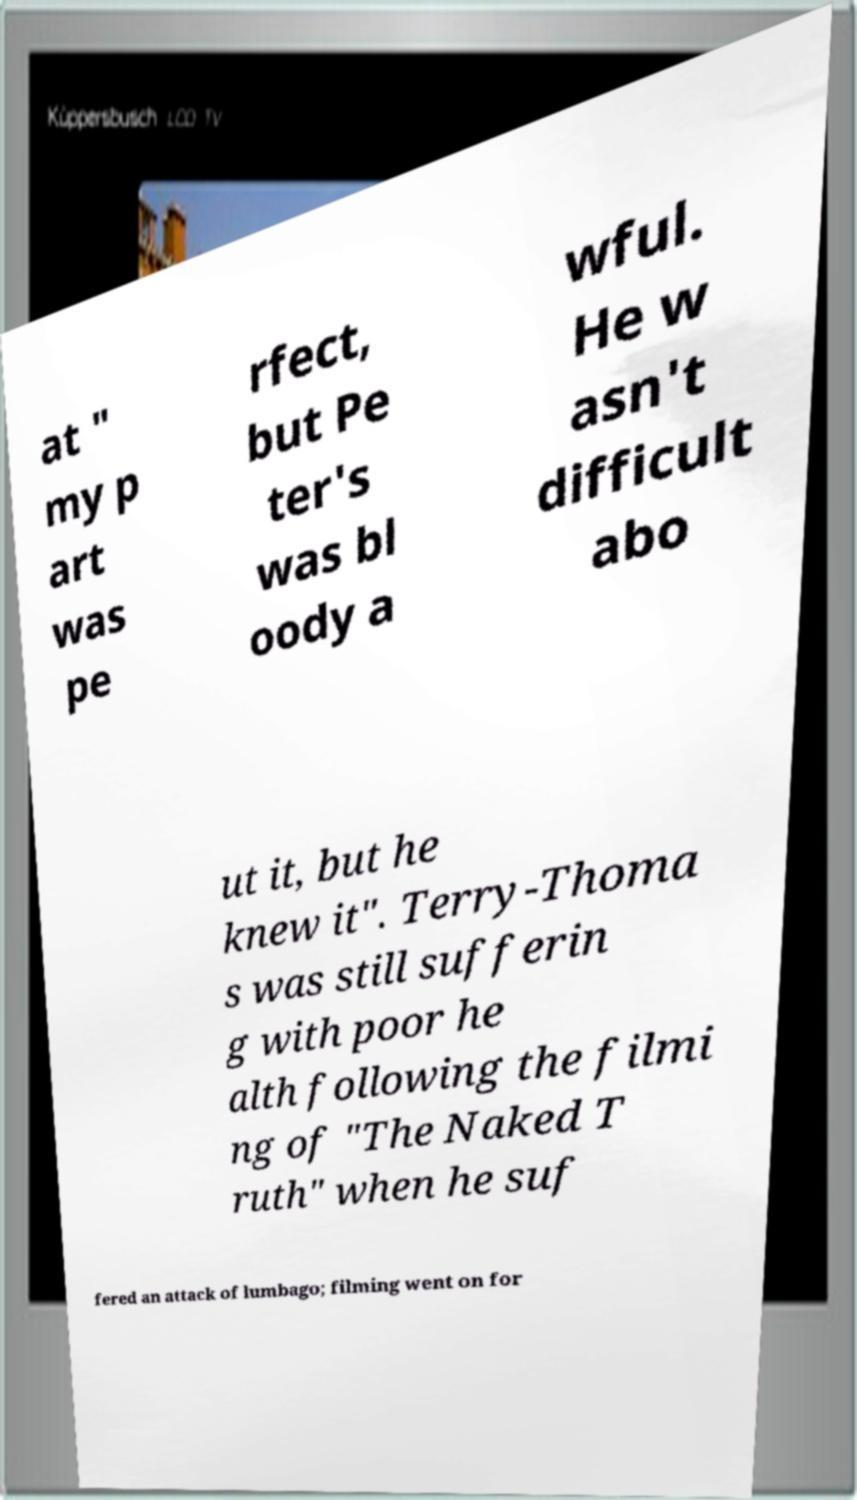There's text embedded in this image that I need extracted. Can you transcribe it verbatim? at " my p art was pe rfect, but Pe ter's was bl oody a wful. He w asn't difficult abo ut it, but he knew it". Terry-Thoma s was still sufferin g with poor he alth following the filmi ng of "The Naked T ruth" when he suf fered an attack of lumbago; filming went on for 